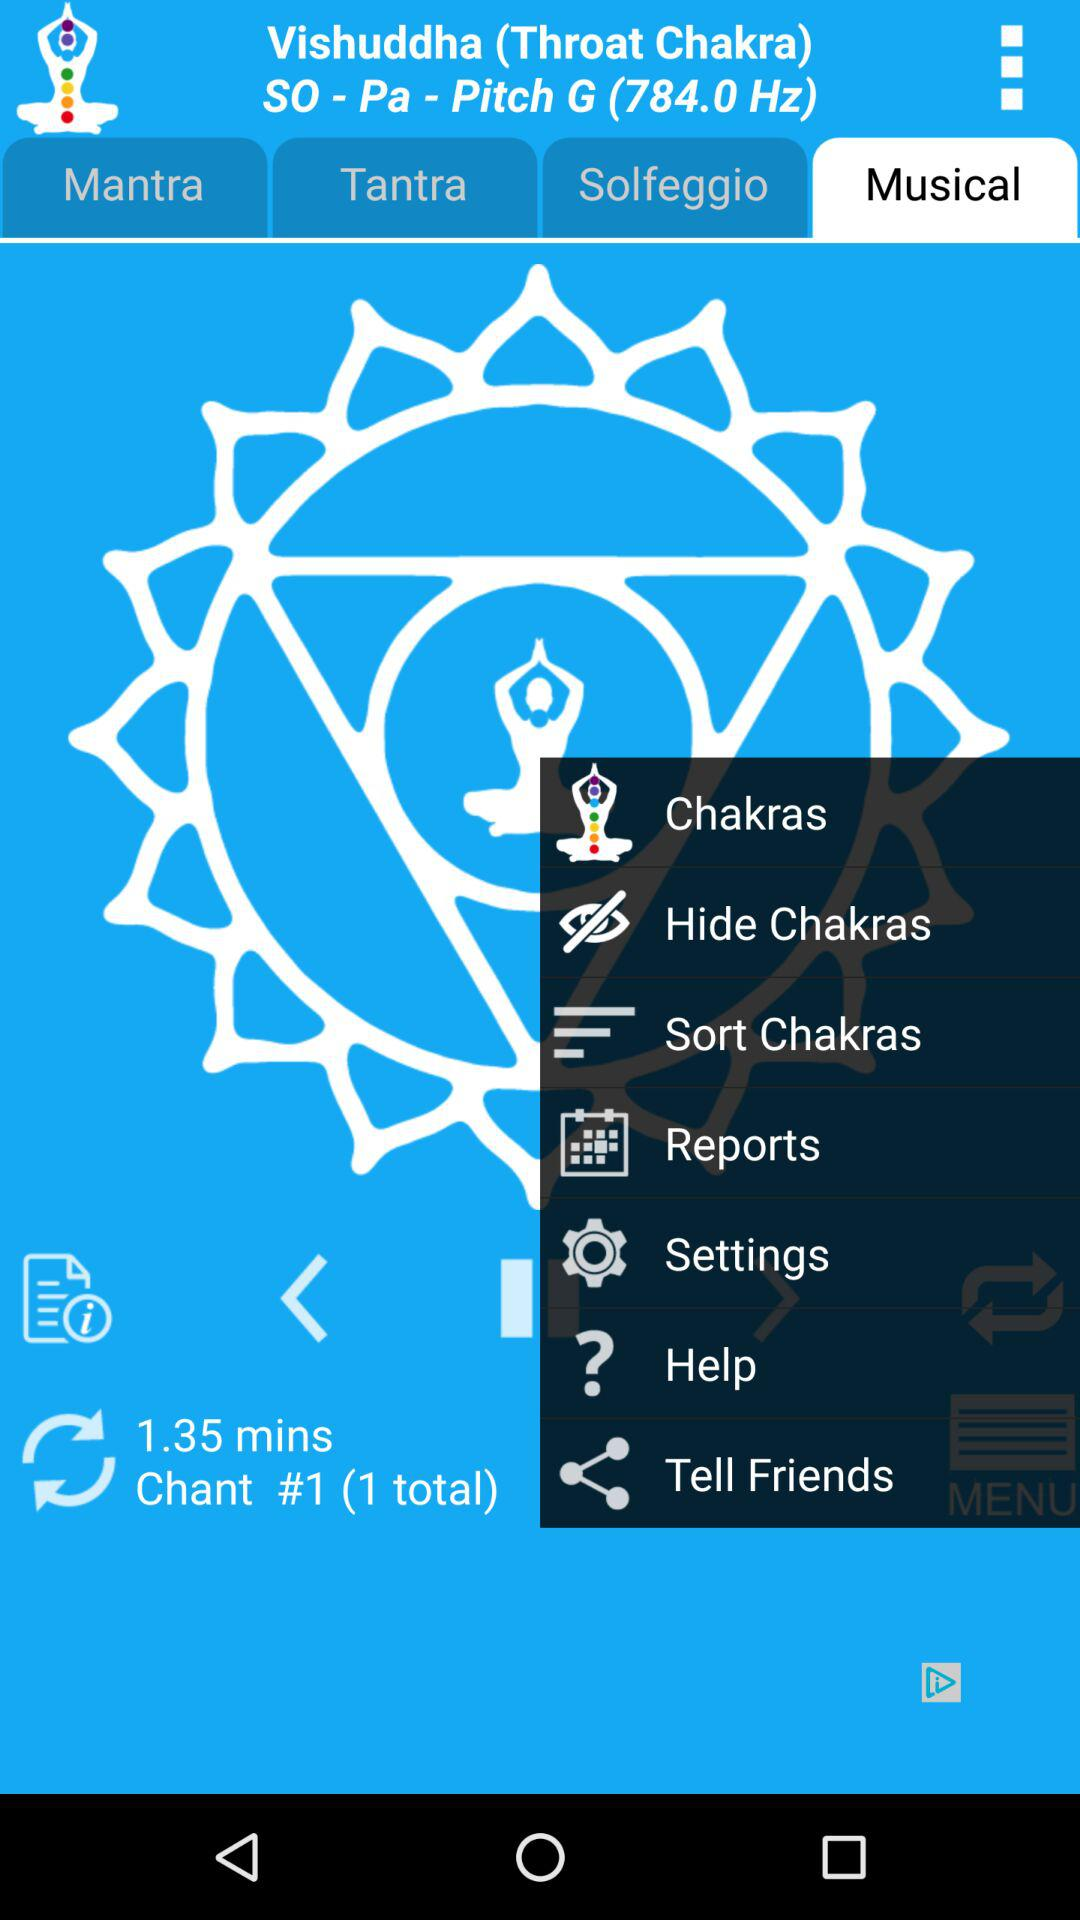What is the duration of the musical, in minutes? The duration of the musical is 1.35 minutes. 